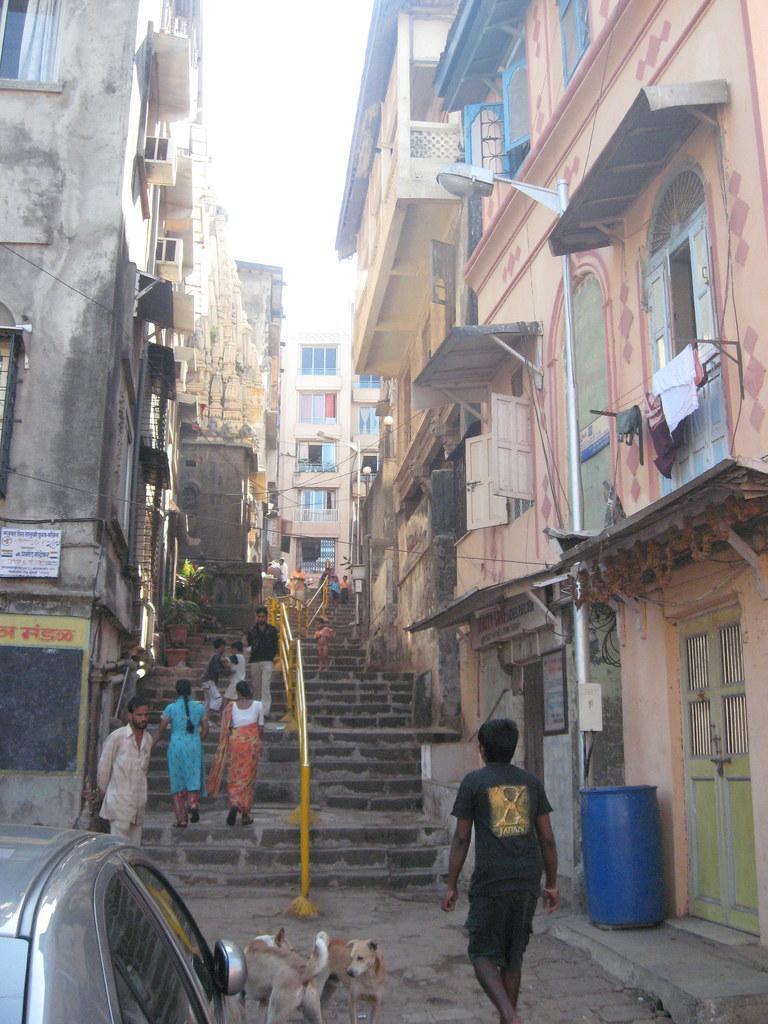Please provide a concise description of this image. In this image there are buildings. At the center of the image there are stairs where people are walking on the stairs. In front of stairs there is a car. Beside the car there are two dogs. At the top there is sky. 